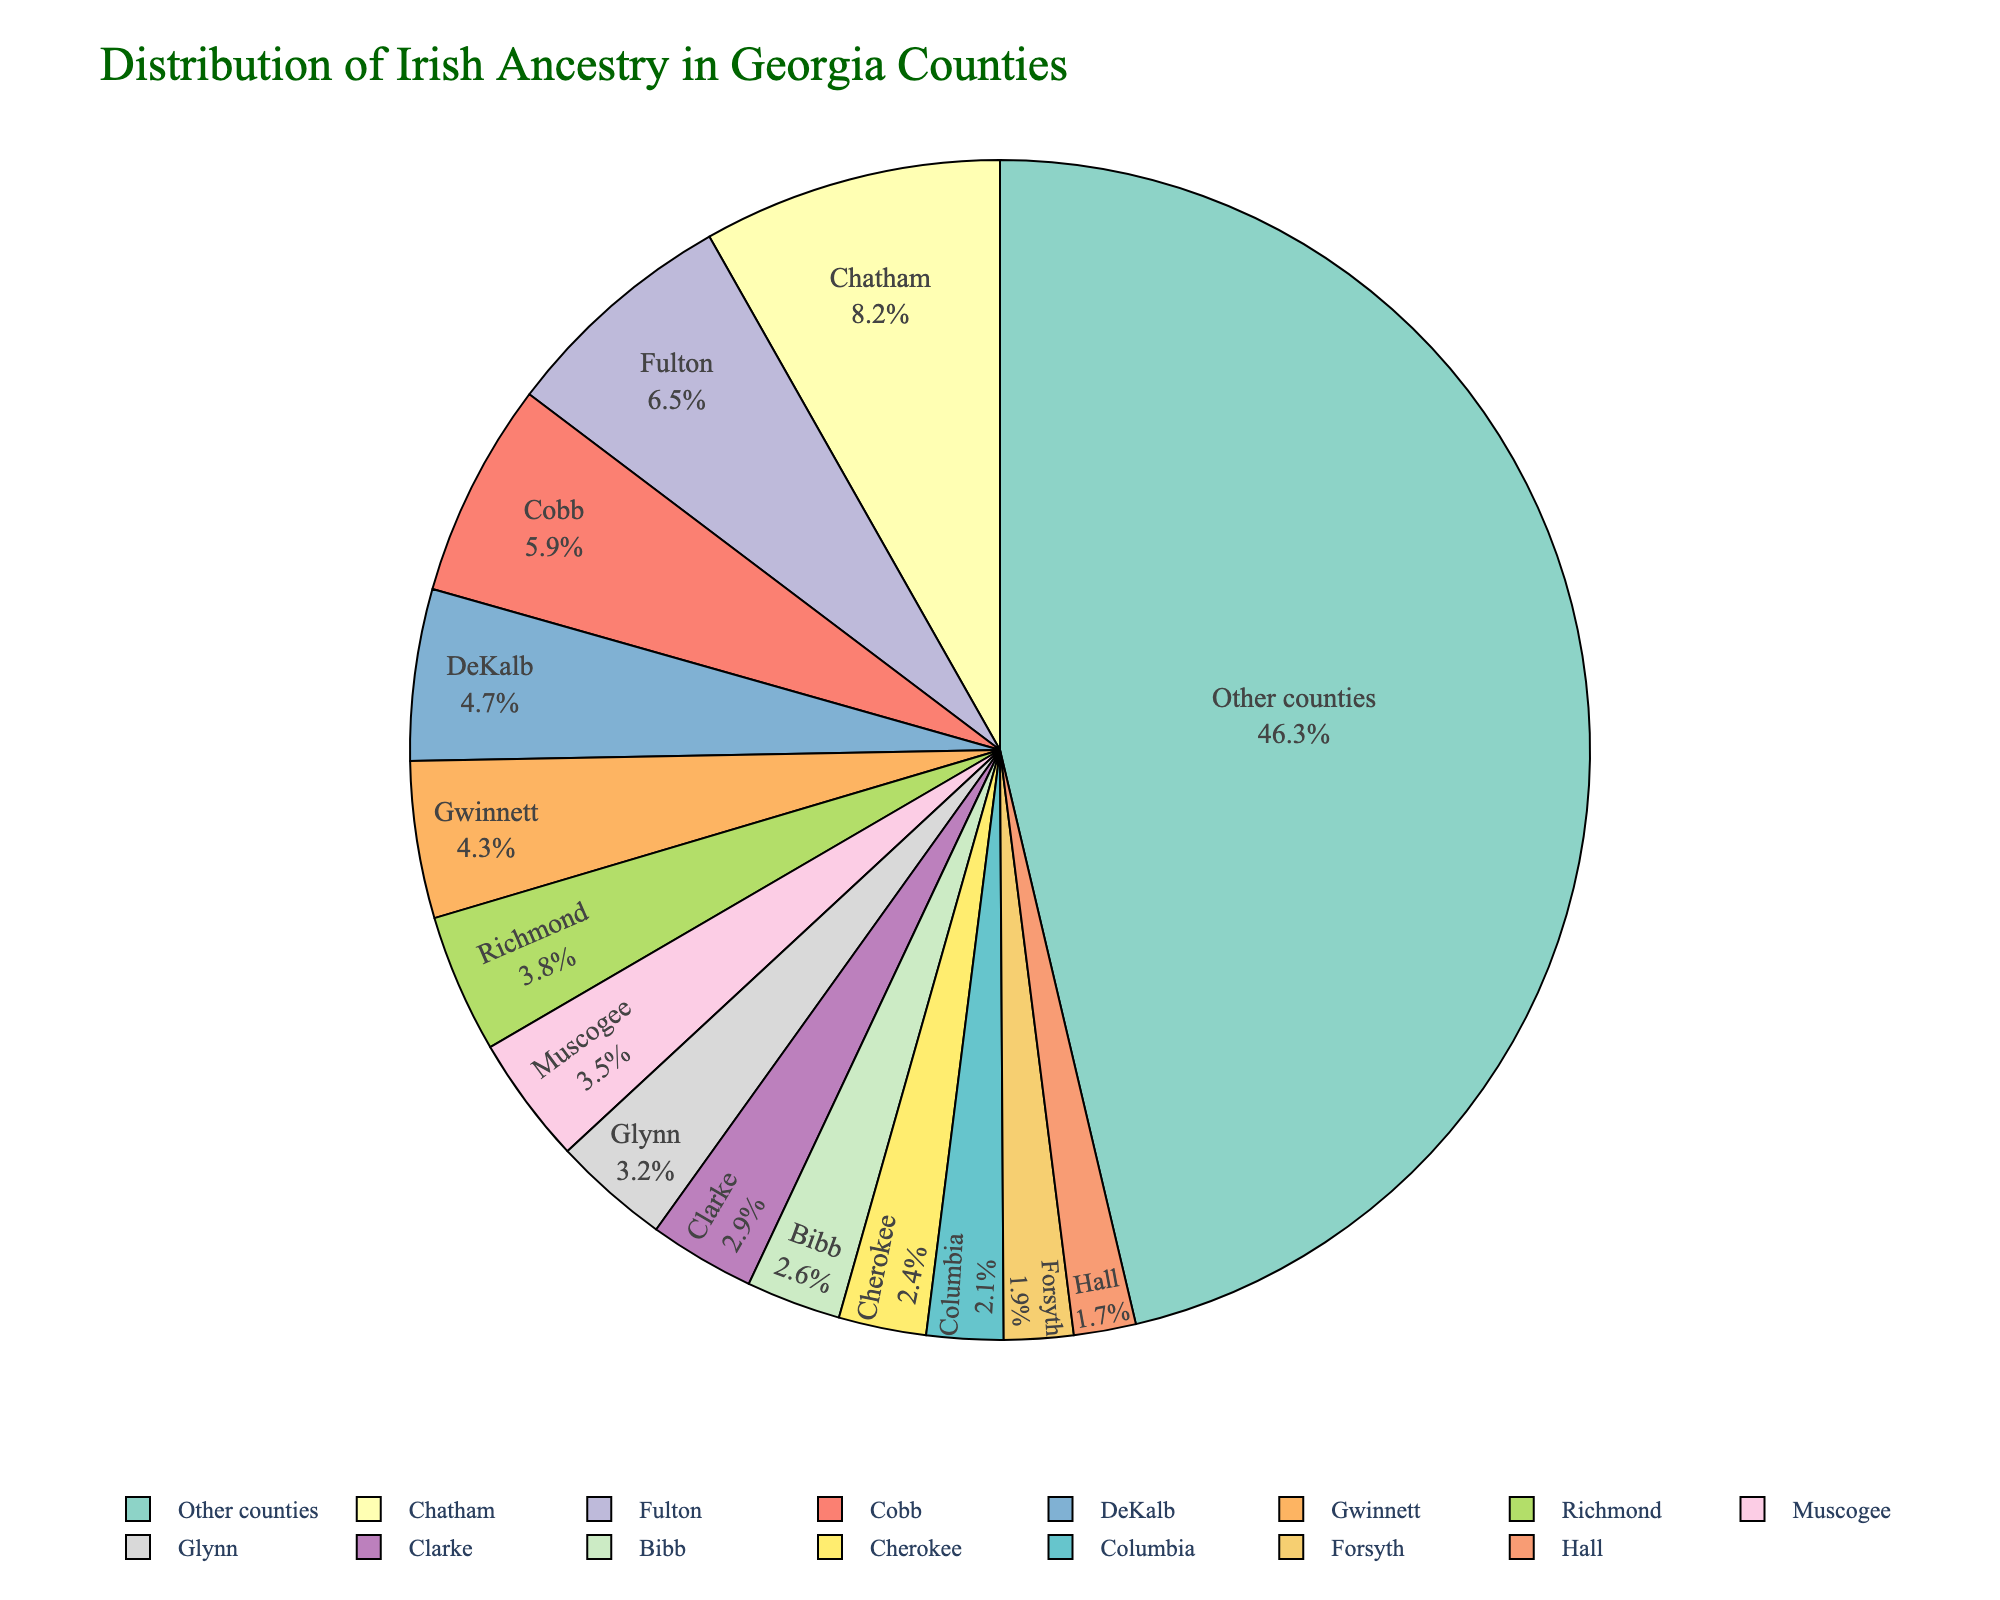What percentage of Irish ancestry is distributed among the top 5 counties? Identify the top 5 counties by their percentage values: Chatham (8.2), Fulton (6.5), Cobb (5.9), DeKalb (4.7), and Gwinnett (4.3). Sum these values: 8.2 + 6.5 + 5.9 + 4.7 + 4.3 = 29.6
Answer: 29.6% Which county has the highest percentage of Irish ancestry? Locate the county with the highest percentage value on the pie chart. Chatham has the highest value at 8.2%.
Answer: Chatham Is the percentage of Irish ancestry in Bibb County more or less than that in Cherokee County? Refer to the percentage values for Bibb (2.6) and Cherokee (2.4). Since 2.6 is greater than 2.4, Bibb has a higher percentage than Cherokee.
Answer: More Which counties contribute to less than 5% of Irish ancestry individually but collectively account for a significant portion when combined? Identify counties with individual percentages less than 5%: Richmond (3.8), Muscogee (3.5), Glynn (3.2), Clarke (2.9), Bibb (2.6), Cherokee (2.4), Columbia (2.1), Forsyth (1.9), Hall (1.7). Add these values together: 3.8 + 3.5 + 3.2 + 2.9 + 2.6 + 2.4 + 2.1 + 1.9 + 1.7 = 23.1
Answer: Richmond, Muscogee, Glynn, Clarke, Bibb, Cherokee, Columbia, Forsyth, Hall, 23.1% Which colors are used to represent Chatham and Fulton counties? Identify the colors on the pie chart corresponding to Chatham and Fulton. Refer to the figure’s legend for accurate color representation.
Answer: Chatham (first color in palette), Fulton (second color in palette) Which county has a nearly equal percentage of Irish ancestry to Glynn County? Look at the percentage for Glynn County (3.2) and identify the county with a similar percentage. Muscogee (3.5) is the closest.
Answer: Muscogee How does the percentage of Irish ancestry in ‘Other counties’ compare to the total percentage of the named counties? Sum the percentages of all named counties: Chatham (8.2), Fulton (6.5), Cobb (5.9), DeKalb (4.7), Gwinnett (4.3), Richmond (3.8), Muscogee (3.5), Glynn (3.2), Clarke (2.9), Bibb (2.6), Cherokee (2.4), Columbia (2.1), Forsyth (1.9), Hall (1.7). Then calculate: 8.2 + 6.5 + 5.9 + 4.7 + 4.3 + 3.8 + 3.5 + 3.2 + 2.9 + 2.6 + 2.4 + 2.1 + 1.9 + 1.7 = 53.7. Since ‘Other counties’ have 46.3%, it’s less than the total of the named counties' percentage (53.7).
Answer: Less 